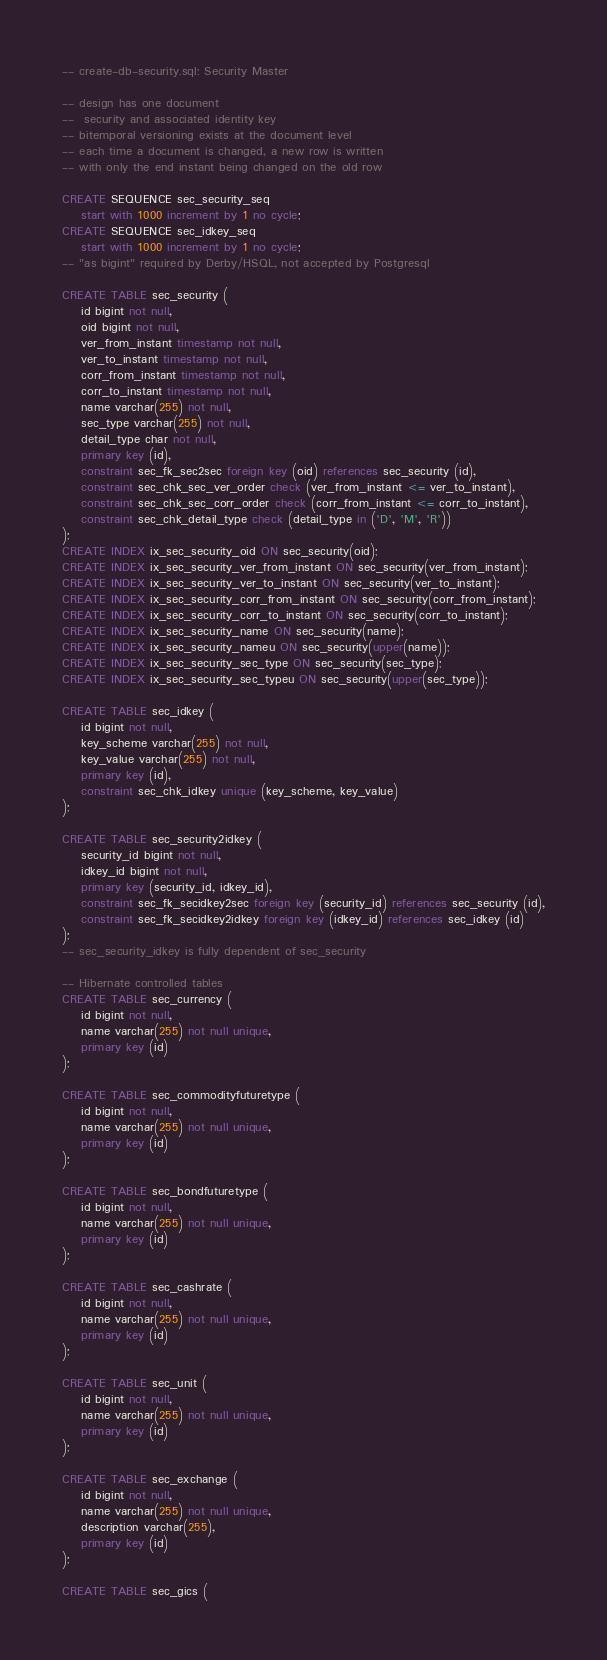Convert code to text. <code><loc_0><loc_0><loc_500><loc_500><_SQL_>
-- create-db-security.sql: Security Master

-- design has one document
--  security and associated identity key
-- bitemporal versioning exists at the document level
-- each time a document is changed, a new row is written
-- with only the end instant being changed on the old row

CREATE SEQUENCE sec_security_seq
    start with 1000 increment by 1 no cycle;
CREATE SEQUENCE sec_idkey_seq
    start with 1000 increment by 1 no cycle;
-- "as bigint" required by Derby/HSQL, not accepted by Postgresql

CREATE TABLE sec_security (
    id bigint not null,
    oid bigint not null,
    ver_from_instant timestamp not null,
    ver_to_instant timestamp not null,
    corr_from_instant timestamp not null,
    corr_to_instant timestamp not null,
    name varchar(255) not null,
    sec_type varchar(255) not null,
    detail_type char not null,
    primary key (id),
    constraint sec_fk_sec2sec foreign key (oid) references sec_security (id),
    constraint sec_chk_sec_ver_order check (ver_from_instant <= ver_to_instant),
    constraint sec_chk_sec_corr_order check (corr_from_instant <= corr_to_instant),
    constraint sec_chk_detail_type check (detail_type in ('D', 'M', 'R'))
);
CREATE INDEX ix_sec_security_oid ON sec_security(oid);
CREATE INDEX ix_sec_security_ver_from_instant ON sec_security(ver_from_instant);
CREATE INDEX ix_sec_security_ver_to_instant ON sec_security(ver_to_instant);
CREATE INDEX ix_sec_security_corr_from_instant ON sec_security(corr_from_instant);
CREATE INDEX ix_sec_security_corr_to_instant ON sec_security(corr_to_instant);
CREATE INDEX ix_sec_security_name ON sec_security(name);
CREATE INDEX ix_sec_security_nameu ON sec_security(upper(name));
CREATE INDEX ix_sec_security_sec_type ON sec_security(sec_type);
CREATE INDEX ix_sec_security_sec_typeu ON sec_security(upper(sec_type));

CREATE TABLE sec_idkey (
    id bigint not null,
    key_scheme varchar(255) not null,
    key_value varchar(255) not null,
    primary key (id),
    constraint sec_chk_idkey unique (key_scheme, key_value)
);

CREATE TABLE sec_security2idkey (
    security_id bigint not null,
    idkey_id bigint not null,
    primary key (security_id, idkey_id),
    constraint sec_fk_secidkey2sec foreign key (security_id) references sec_security (id),
    constraint sec_fk_secidkey2idkey foreign key (idkey_id) references sec_idkey (id)
);
-- sec_security_idkey is fully dependent of sec_security

-- Hibernate controlled tables
CREATE TABLE sec_currency (
    id bigint not null,
    name varchar(255) not null unique,
    primary key (id)
);

CREATE TABLE sec_commodityfuturetype (
    id bigint not null,
    name varchar(255) not null unique,
    primary key (id)
);

CREATE TABLE sec_bondfuturetype (
    id bigint not null,
    name varchar(255) not null unique,
    primary key (id)
);

CREATE TABLE sec_cashrate (
    id bigint not null,
    name varchar(255) not null unique,
    primary key (id)
);

CREATE TABLE sec_unit (
    id bigint not null,
    name varchar(255) not null unique,
    primary key (id)
);

CREATE TABLE sec_exchange (
    id bigint not null,
    name varchar(255) not null unique,
    description varchar(255),
    primary key (id)
);

CREATE TABLE sec_gics (</code> 